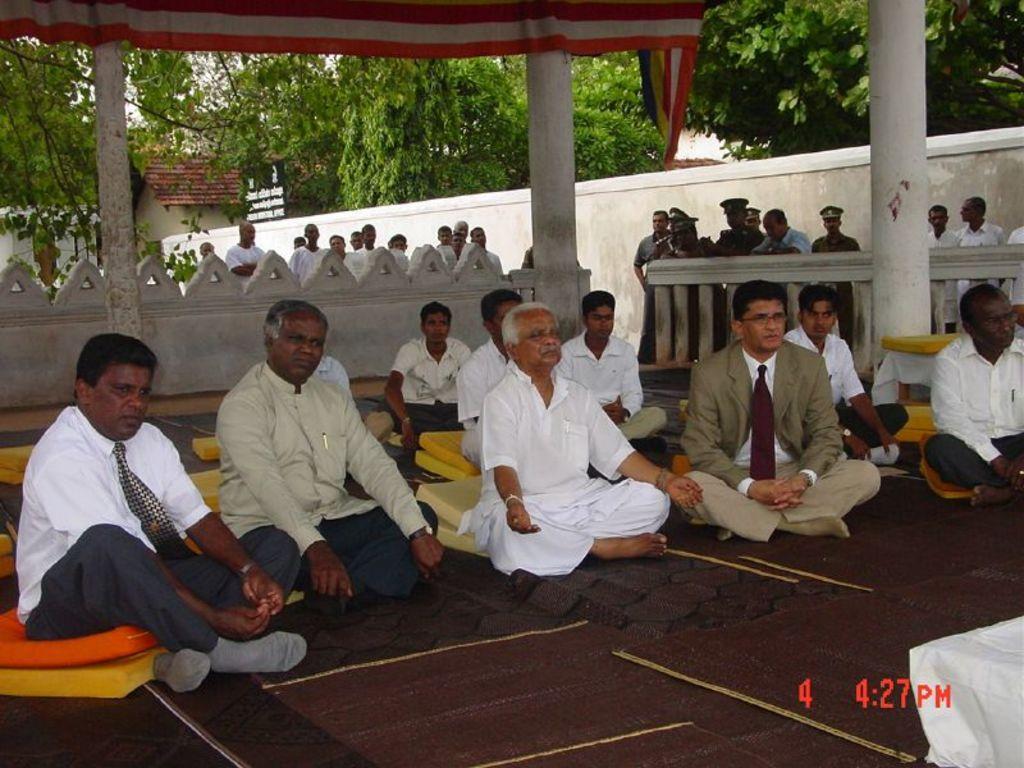How would you summarize this image in a sentence or two? In this image I can see number of people where in the front I can see few are sitting and in the background I can see number of people are standing. In the front I can see people are sitting on cushions. I can also see floor mattress, a white colour cloth and on the right bottom side I can see a watermark. In the background I can see two pillars, railing, the wall, number of trees, a cloth and a building. 